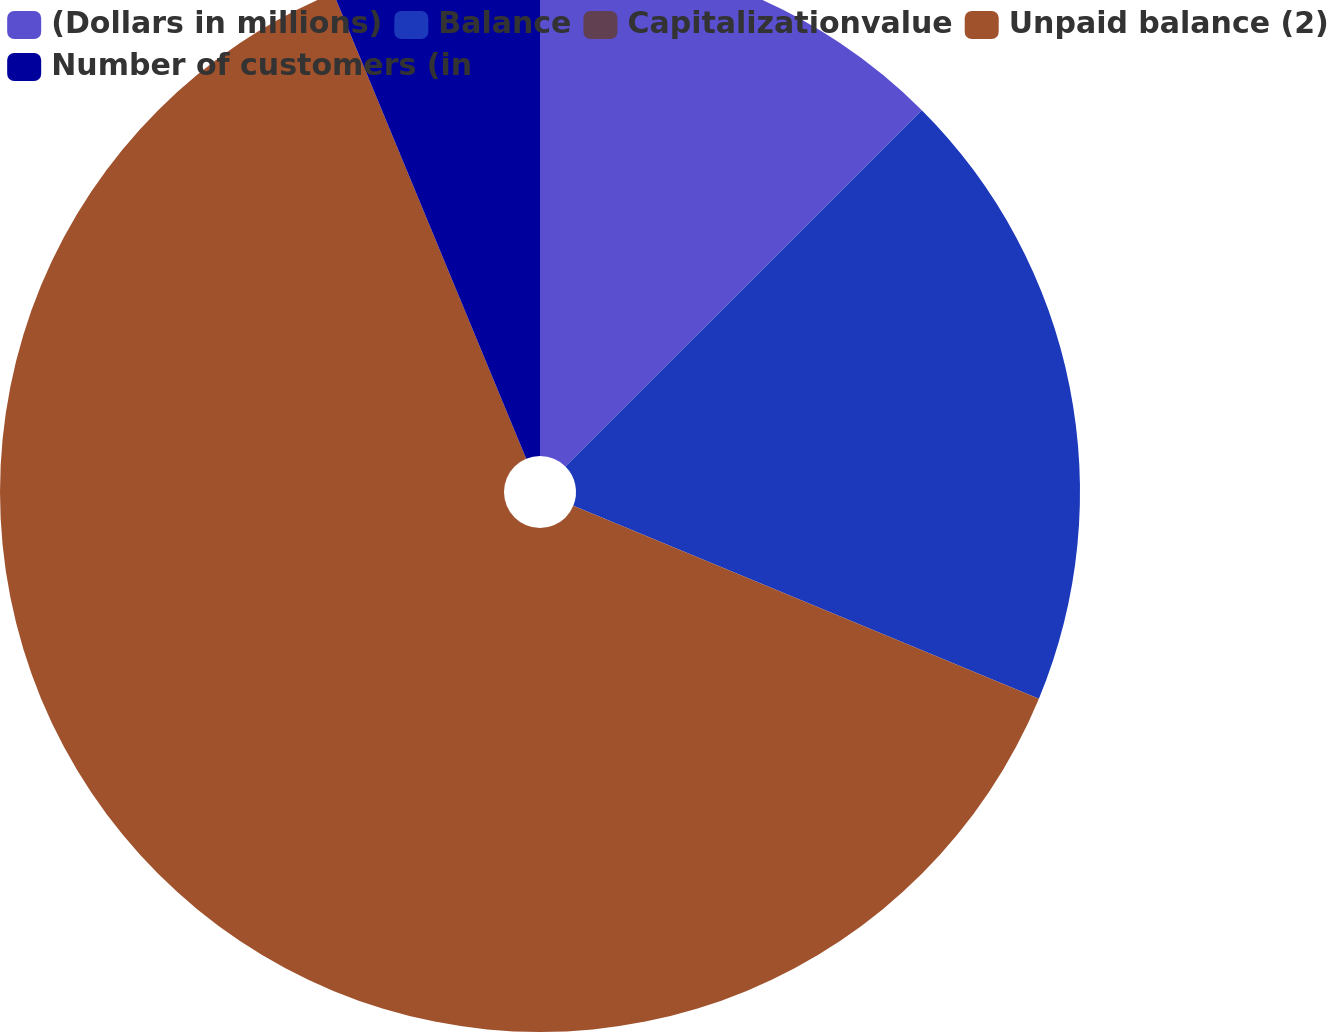Convert chart to OTSL. <chart><loc_0><loc_0><loc_500><loc_500><pie_chart><fcel>(Dollars in millions)<fcel>Balance<fcel>Capitalizationvalue<fcel>Unpaid balance (2)<fcel>Number of customers (in<nl><fcel>12.5%<fcel>18.75%<fcel>0.0%<fcel>62.5%<fcel>6.25%<nl></chart> 